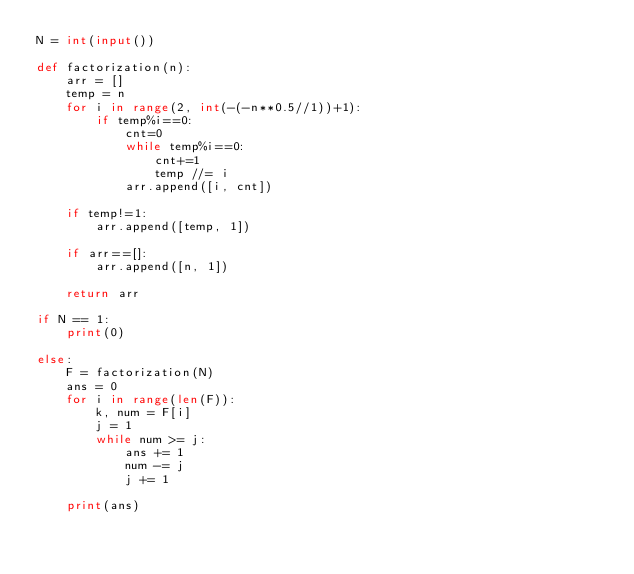<code> <loc_0><loc_0><loc_500><loc_500><_Python_>N = int(input())

def factorization(n):
    arr = []
    temp = n
    for i in range(2, int(-(-n**0.5//1))+1):
        if temp%i==0:
            cnt=0
            while temp%i==0:
                cnt+=1
                temp //= i
            arr.append([i, cnt])

    if temp!=1:
        arr.append([temp, 1])

    if arr==[]:
        arr.append([n, 1])

    return arr

if N == 1:
    print(0)

else:
    F = factorization(N)
    ans = 0
    for i in range(len(F)):
        k, num = F[i]
        j = 1
        while num >= j:
            ans += 1
            num -= j
            j += 1

    print(ans)</code> 